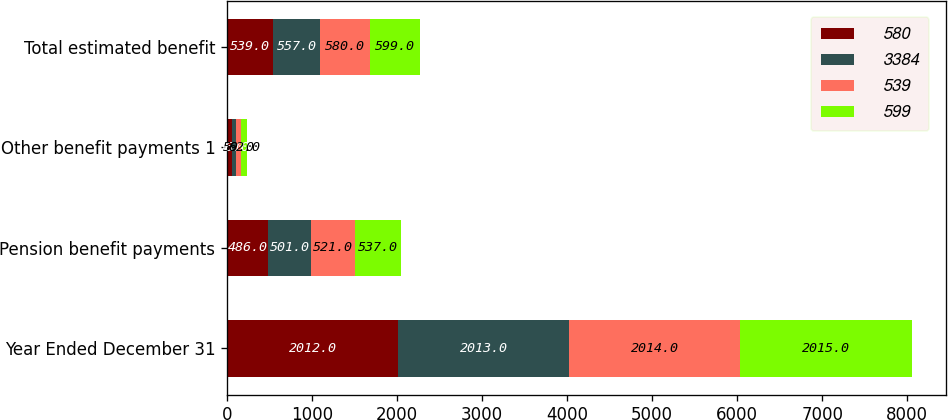<chart> <loc_0><loc_0><loc_500><loc_500><stacked_bar_chart><ecel><fcel>Year Ended December 31<fcel>Pension benefit payments<fcel>Other benefit payments 1<fcel>Total estimated benefit<nl><fcel>580<fcel>2012<fcel>486<fcel>53<fcel>539<nl><fcel>3384<fcel>2013<fcel>501<fcel>56<fcel>557<nl><fcel>539<fcel>2014<fcel>521<fcel>59<fcel>580<nl><fcel>599<fcel>2015<fcel>537<fcel>62<fcel>599<nl></chart> 